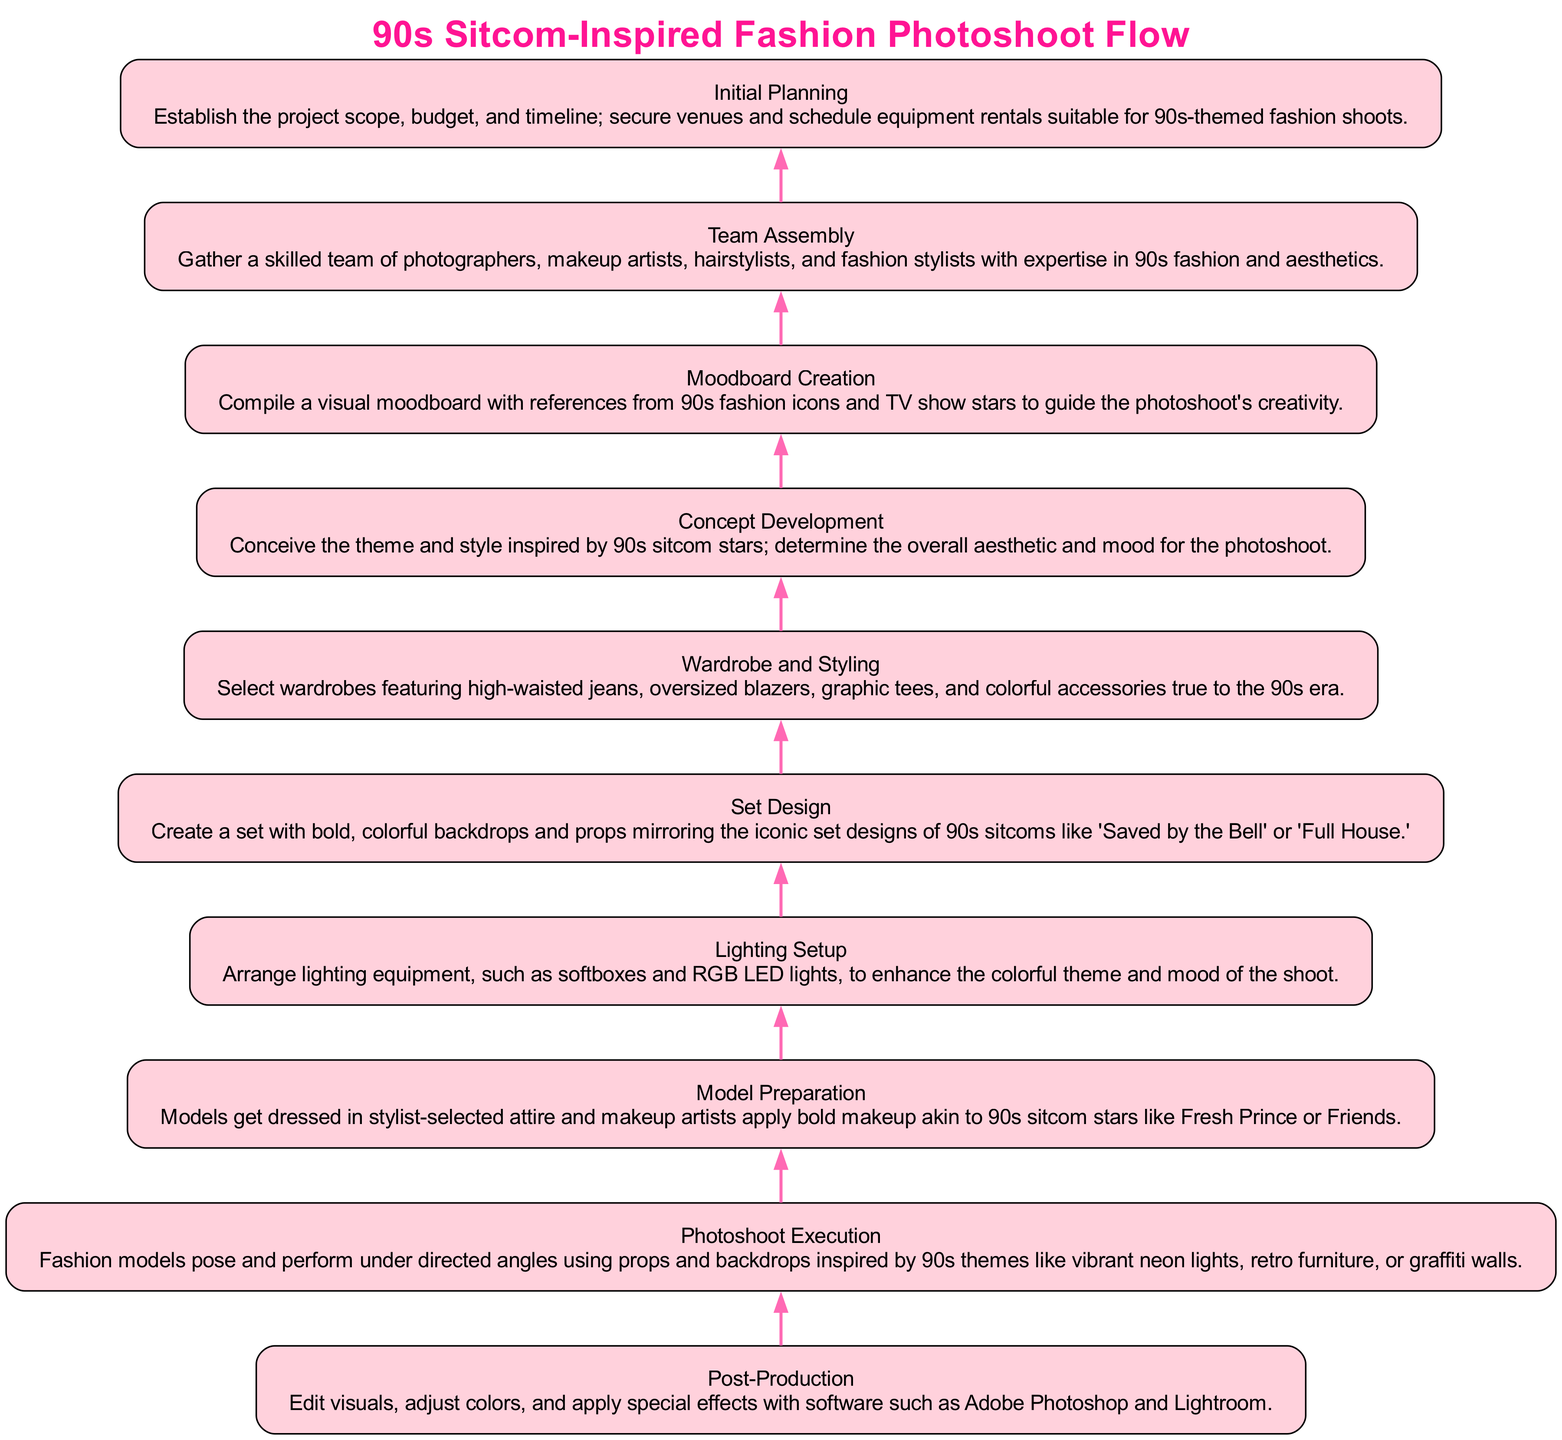What is the first step in the flow? The flow starts from the bottom to the top, with "Initial Planning" being the first element in the diagram.
Answer: Initial Planning How many nodes are present in the diagram? By counting each of the nodes listed, there are a total of 10 nodes in the diagram.
Answer: 10 Which stage follows "Moodboard Creation"? "Concept Development" directly follows "Moodboard Creation" as per the flow of the diagram.
Answer: Concept Development What step comes immediately before "Set Design"? "Wardrobe and Styling" is the step that comes immediately before "Set Design" in the hierarchical flow chart.
Answer: Wardrobe and Styling What is the main focus of the "Photoshoot Execution"? The description of "Photoshoot Execution" details that it focuses on how fashion models perform and pose during the photoshoot.
Answer: Fashion models pose Which node has the longest description? Upon reviewing the descriptions, "Photoshoot Execution" contains the most information and is the longest description.
Answer: Photoshoot Execution How does "Lighting Setup" relate to the overall theme? "Lighting Setup" is connected to setting the mood through lighting equipment, which enhances the colorful 90s-themed atmosphere of the shoot.
Answer: Enhances the colorful theme What element directly influences "Model Preparation"? "Wardrobe and Styling" directly influences "Model Preparation" as the styling chosen informs the attire models will wear.
Answer: Wardrobe and Styling What is the last step in the flow? The final element, at the top of the flow, is "Post-Production" which represents the last phase of the process.
Answer: Post-Production 